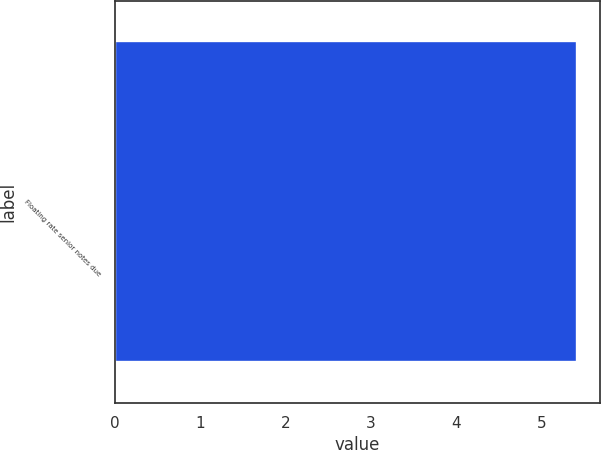Convert chart. <chart><loc_0><loc_0><loc_500><loc_500><bar_chart><fcel>Floating rate senior notes due<nl><fcel>5.42<nl></chart> 